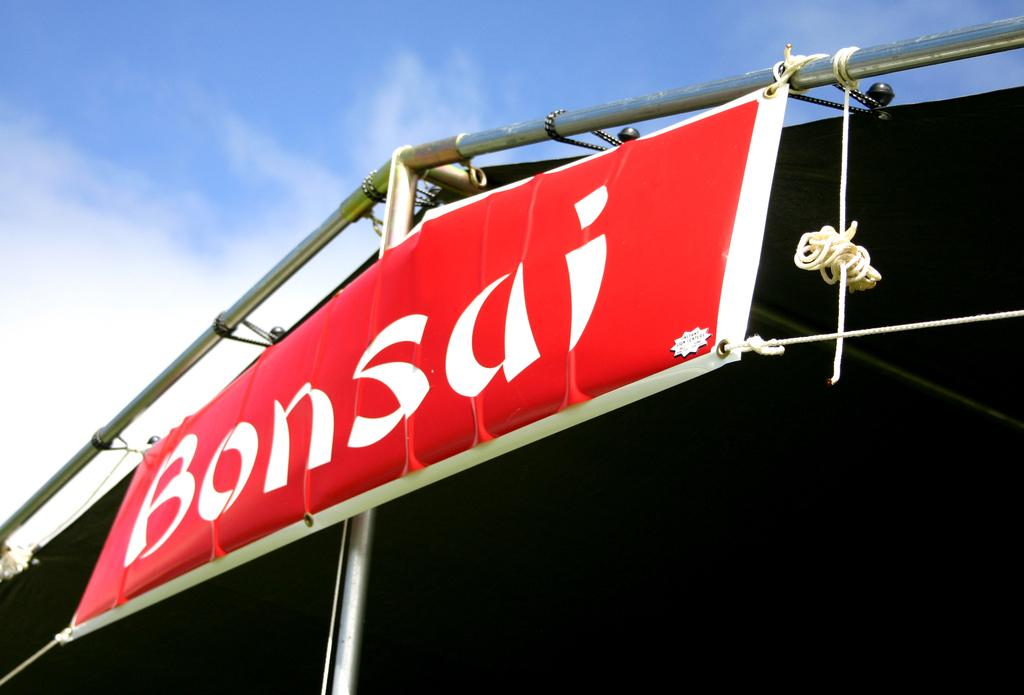What is hanging in the image? There is a banner in the image. What are the banner attached to? The banner is attached to ropes and rods in the image. What else can be seen in the image besides the banner? There are other objects in the image. What is visible in the background of the image? There is a shed and the sky visible in the background of the image. How many birds can be seen touching the ropes in the image? There are no birds present in the image, and therefore no birds can be seen touching the ropes. 